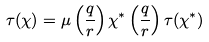<formula> <loc_0><loc_0><loc_500><loc_500>\tau ( \chi ) = \mu \left ( \frac { q } { r } \right ) \chi ^ { * } \left ( \frac { q } { r } \right ) \tau ( \chi ^ { * } )</formula> 